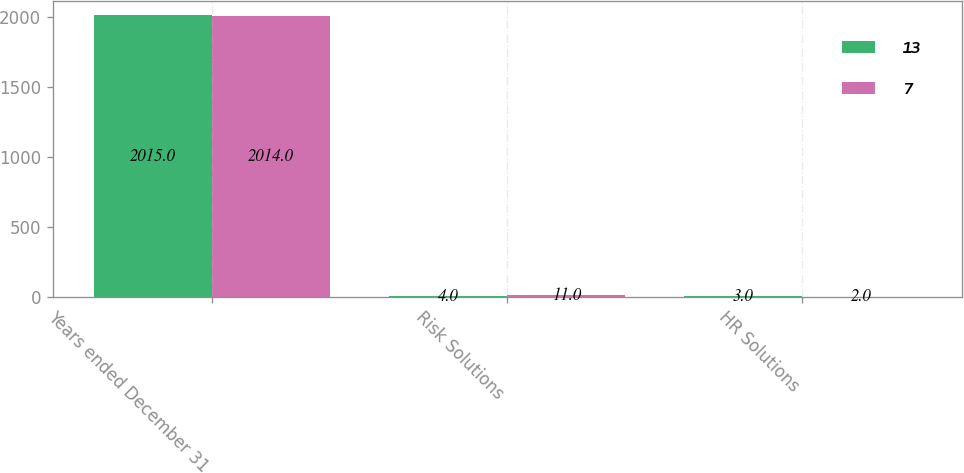<chart> <loc_0><loc_0><loc_500><loc_500><stacked_bar_chart><ecel><fcel>Years ended December 31<fcel>Risk Solutions<fcel>HR Solutions<nl><fcel>13<fcel>2015<fcel>4<fcel>3<nl><fcel>7<fcel>2014<fcel>11<fcel>2<nl></chart> 